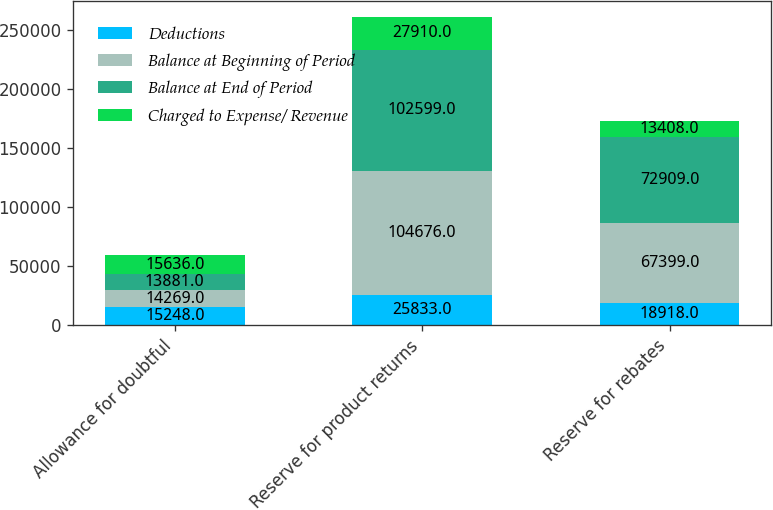Convert chart to OTSL. <chart><loc_0><loc_0><loc_500><loc_500><stacked_bar_chart><ecel><fcel>Allowance for doubtful<fcel>Reserve for product returns<fcel>Reserve for rebates<nl><fcel>Deductions<fcel>15248<fcel>25833<fcel>18918<nl><fcel>Balance at Beginning of Period<fcel>14269<fcel>104676<fcel>67399<nl><fcel>Balance at End of Period<fcel>13881<fcel>102599<fcel>72909<nl><fcel>Charged to Expense/ Revenue<fcel>15636<fcel>27910<fcel>13408<nl></chart> 